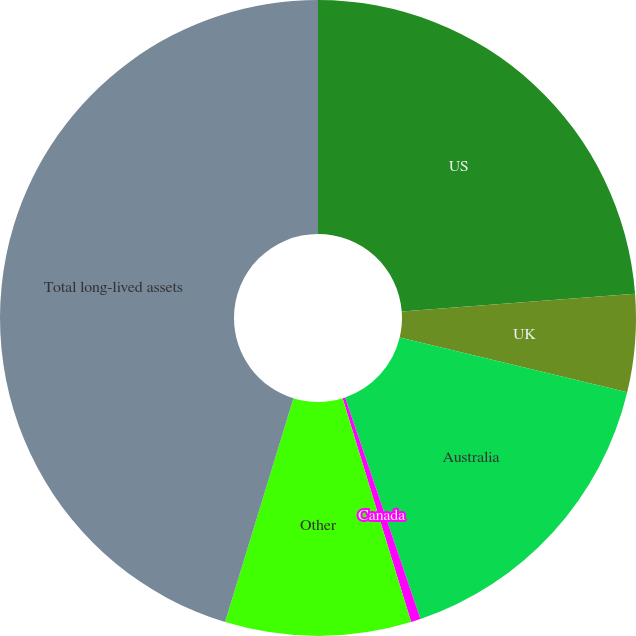Convert chart. <chart><loc_0><loc_0><loc_500><loc_500><pie_chart><fcel>US<fcel>UK<fcel>Australia<fcel>Canada<fcel>Other<fcel>Total long-lived assets<nl><fcel>23.78%<fcel>4.97%<fcel>16.03%<fcel>0.49%<fcel>9.45%<fcel>45.28%<nl></chart> 